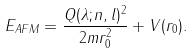<formula> <loc_0><loc_0><loc_500><loc_500>E _ { A F M } = \frac { Q ( \lambda ; n , l ) ^ { 2 } } { 2 m r _ { 0 } ^ { 2 } } + V ( r _ { 0 } ) .</formula> 